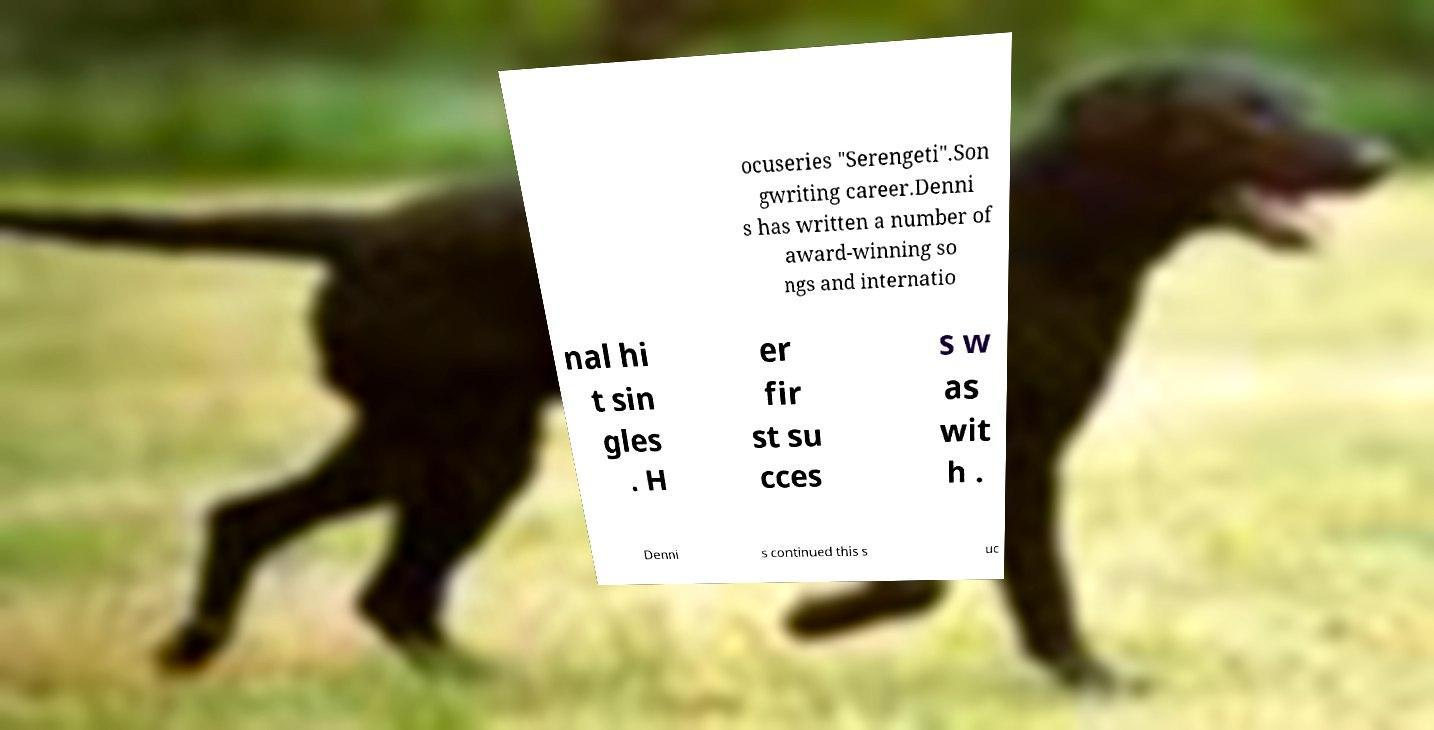I need the written content from this picture converted into text. Can you do that? ocuseries "Serengeti".Son gwriting career.Denni s has written a number of award-winning so ngs and internatio nal hi t sin gles . H er fir st su cces s w as wit h . Denni s continued this s uc 